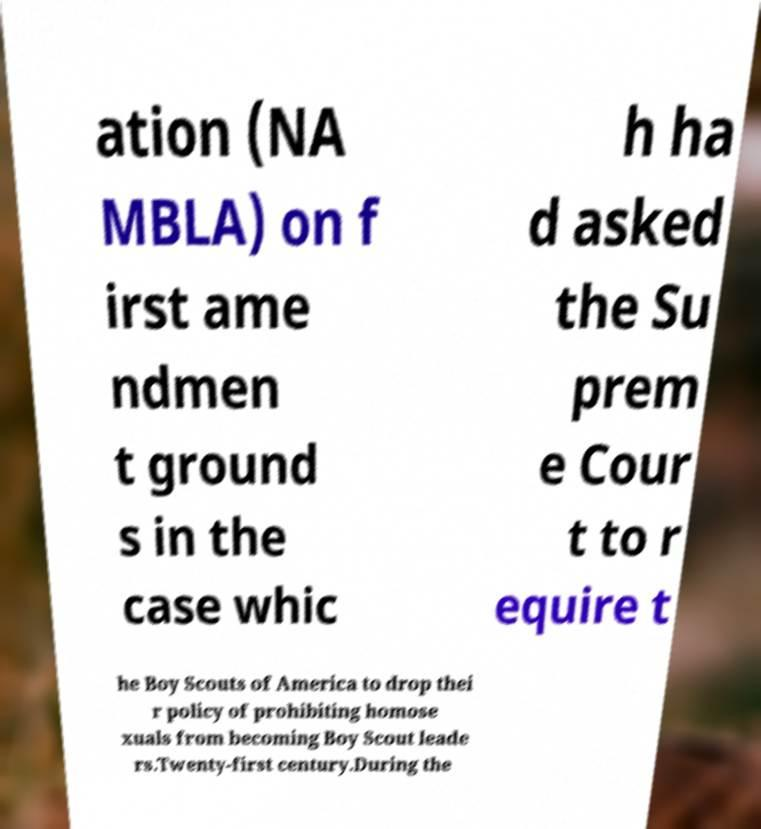Could you assist in decoding the text presented in this image and type it out clearly? ation (NA MBLA) on f irst ame ndmen t ground s in the case whic h ha d asked the Su prem e Cour t to r equire t he Boy Scouts of America to drop thei r policy of prohibiting homose xuals from becoming Boy Scout leade rs.Twenty-first century.During the 